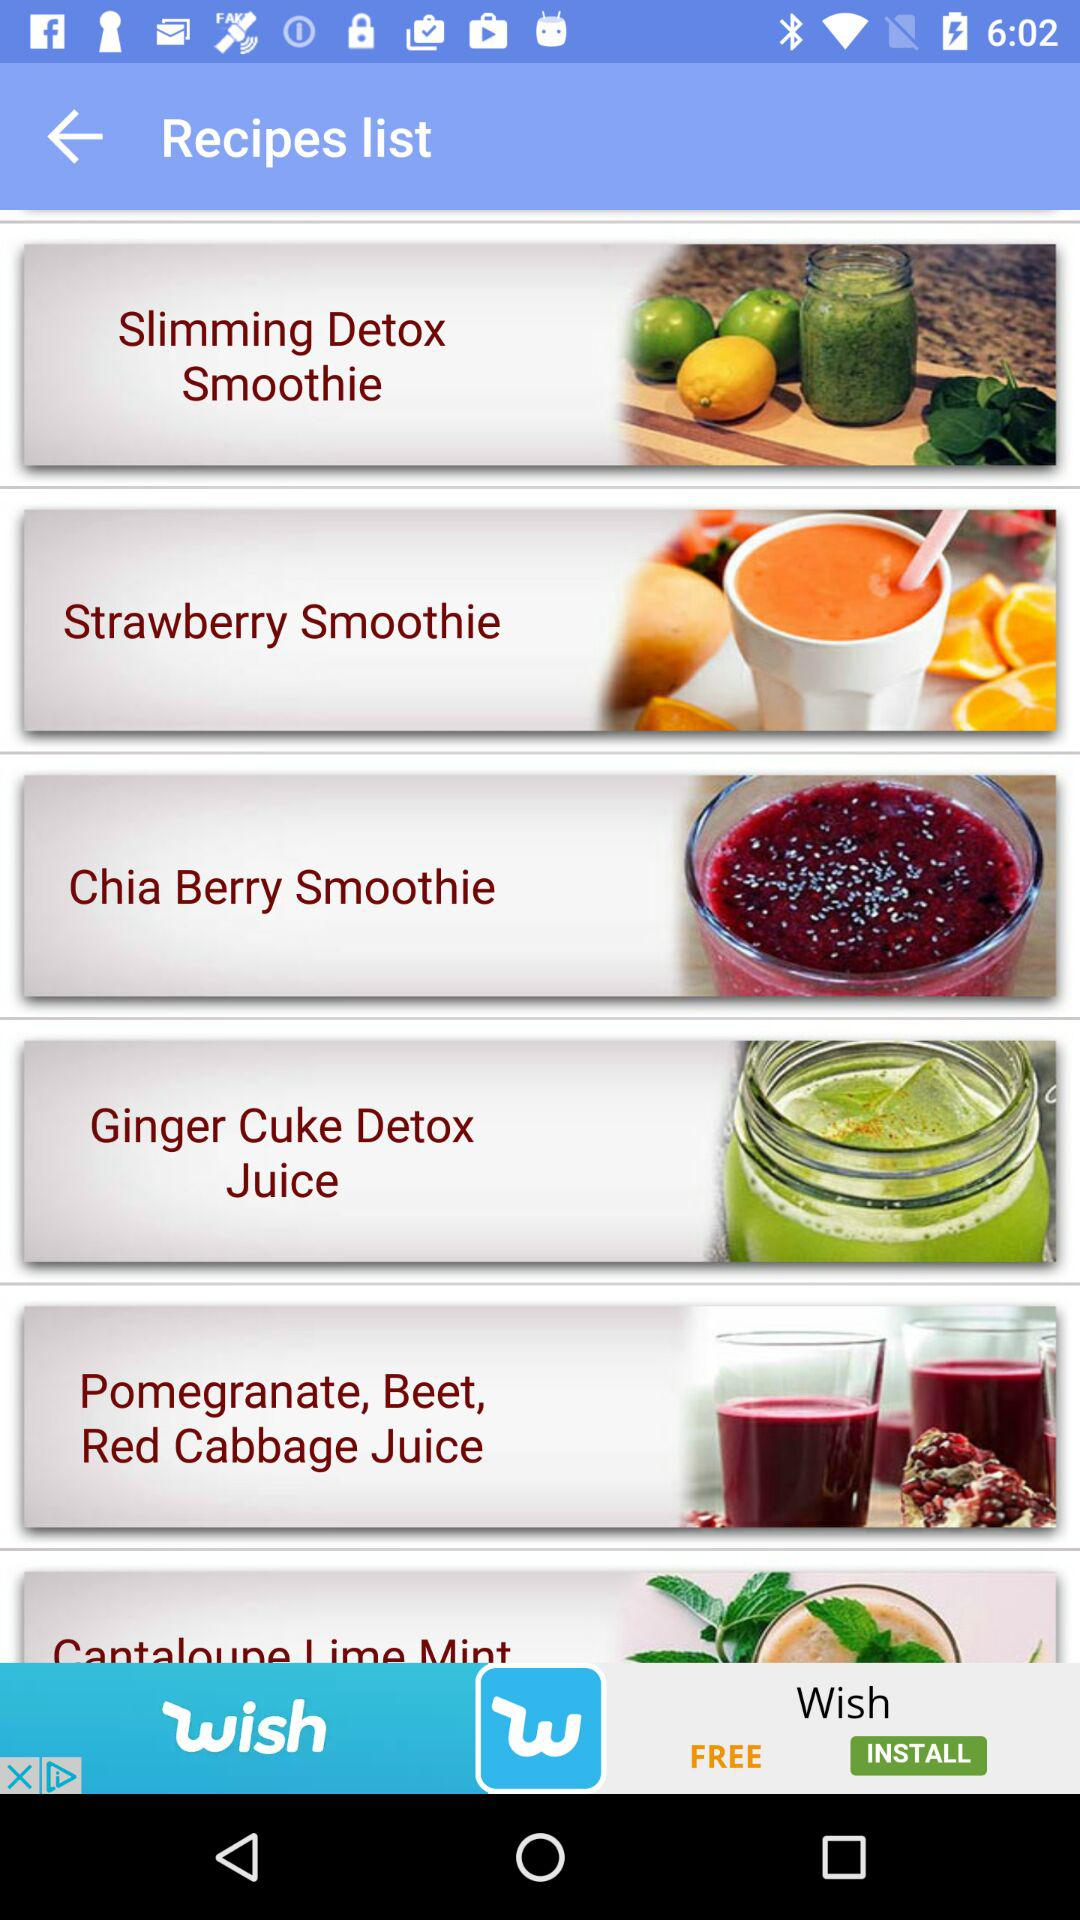Which dishes are given in the list? The dishes given in the list are "Slimming Detox Smoothie", "Strawberry Smoothie", "Chia Berry Smoothie", "Ginger Cuke Detox Juice" and "Pomegranate, Beet, Red Cabbage Juice". 